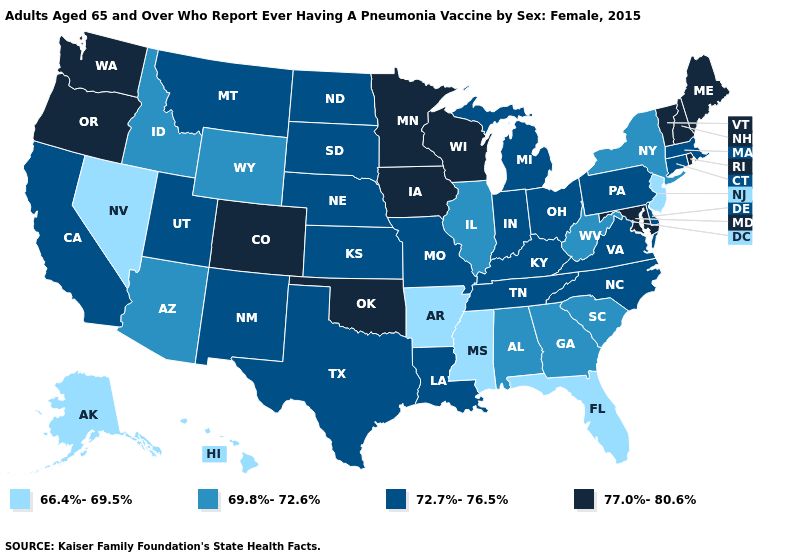What is the value of Massachusetts?
Short answer required. 72.7%-76.5%. How many symbols are there in the legend?
Concise answer only. 4. What is the value of Colorado?
Quick response, please. 77.0%-80.6%. Name the states that have a value in the range 66.4%-69.5%?
Quick response, please. Alaska, Arkansas, Florida, Hawaii, Mississippi, Nevada, New Jersey. Among the states that border Massachusetts , does New Hampshire have the lowest value?
Quick response, please. No. Does Alaska have the lowest value in the USA?
Short answer required. Yes. What is the highest value in the USA?
Give a very brief answer. 77.0%-80.6%. Does the map have missing data?
Keep it brief. No. Name the states that have a value in the range 72.7%-76.5%?
Short answer required. California, Connecticut, Delaware, Indiana, Kansas, Kentucky, Louisiana, Massachusetts, Michigan, Missouri, Montana, Nebraska, New Mexico, North Carolina, North Dakota, Ohio, Pennsylvania, South Dakota, Tennessee, Texas, Utah, Virginia. What is the highest value in states that border Nebraska?
Concise answer only. 77.0%-80.6%. What is the highest value in the West ?
Short answer required. 77.0%-80.6%. What is the value of Hawaii?
Give a very brief answer. 66.4%-69.5%. Which states have the lowest value in the South?
Write a very short answer. Arkansas, Florida, Mississippi. Does the first symbol in the legend represent the smallest category?
Be succinct. Yes. Among the states that border Oregon , does California have the lowest value?
Keep it brief. No. 